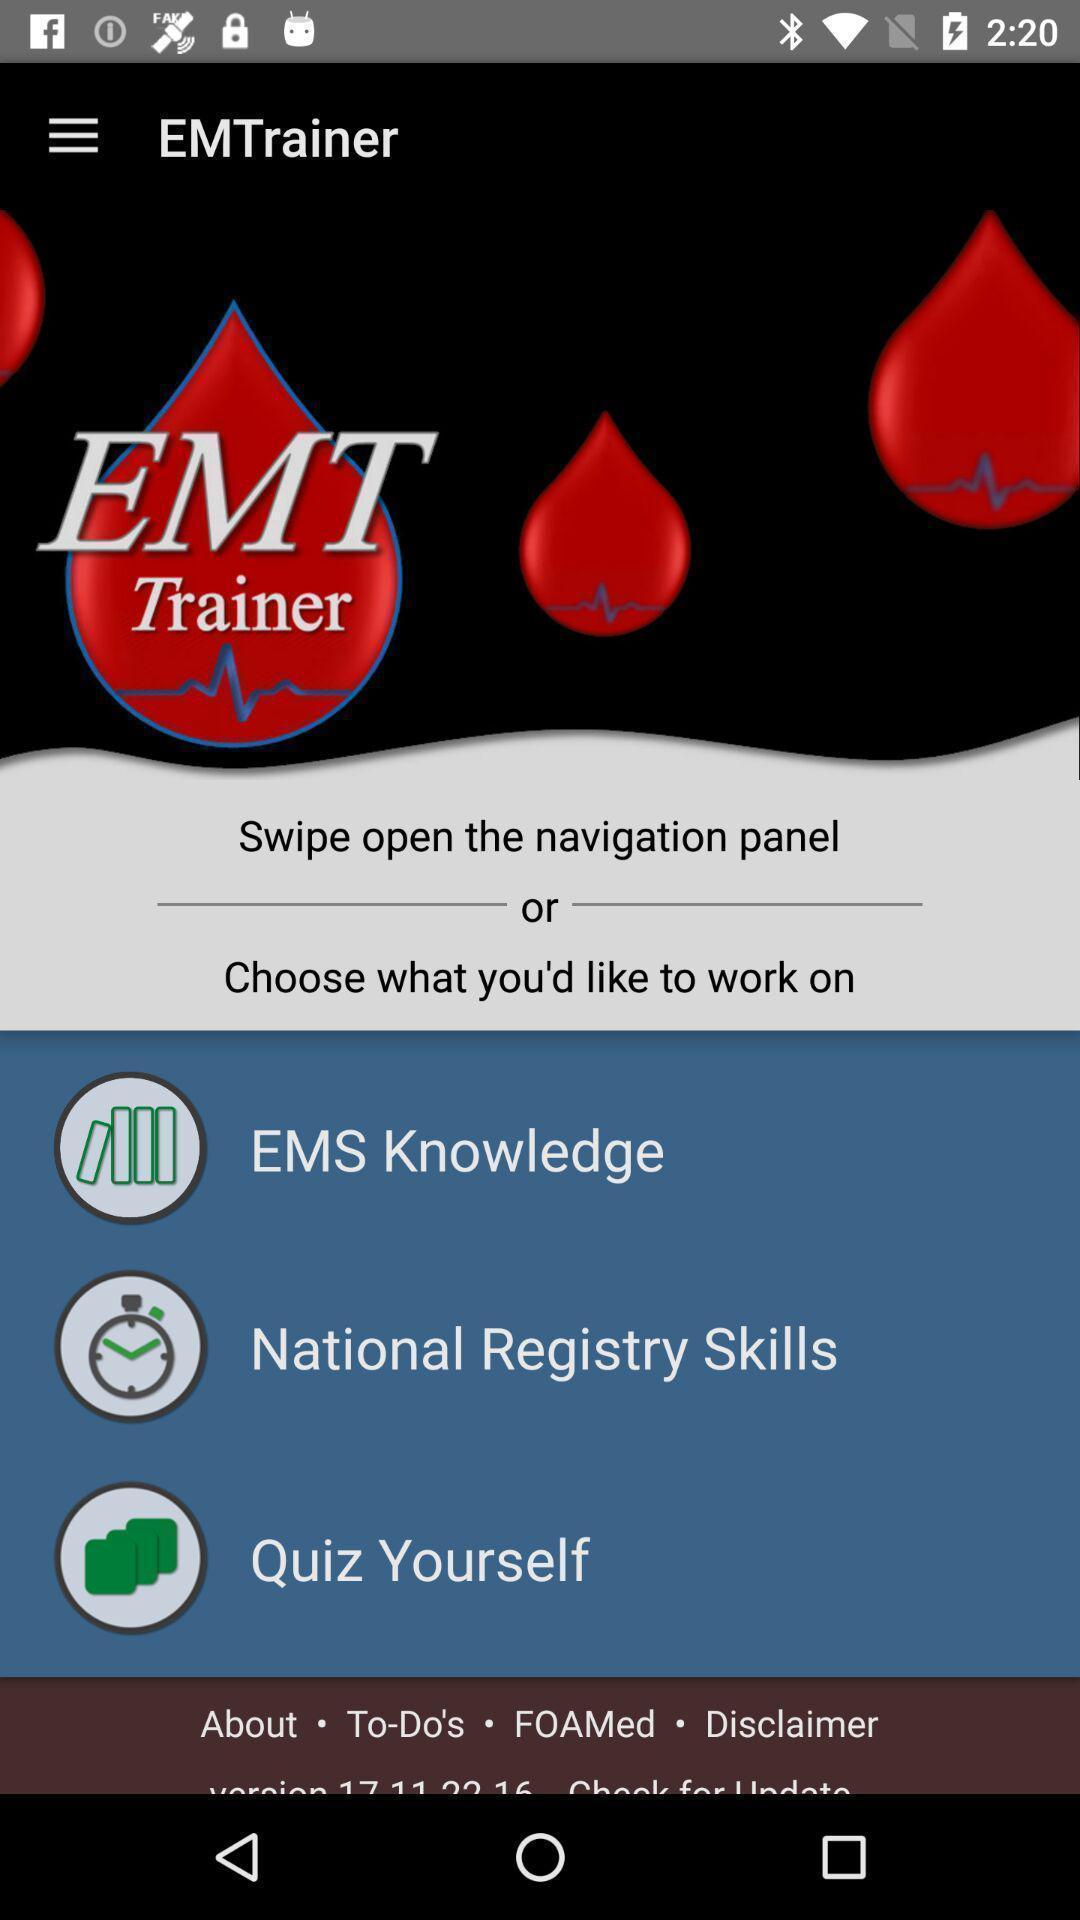Provide a description of this screenshot. Screen displaying the page of a medical app. 